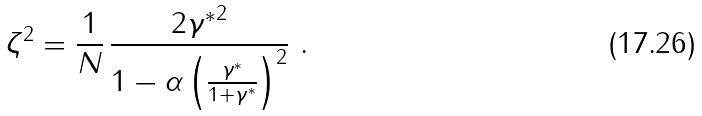Convert formula to latex. <formula><loc_0><loc_0><loc_500><loc_500>\zeta ^ { 2 } = \frac { 1 } { N } \, \frac { 2 { \gamma ^ { * } } ^ { 2 } } { 1 - \alpha \left ( \frac { \gamma ^ { * } } { 1 + \gamma ^ { * } } \right ) ^ { 2 } } \ .</formula> 